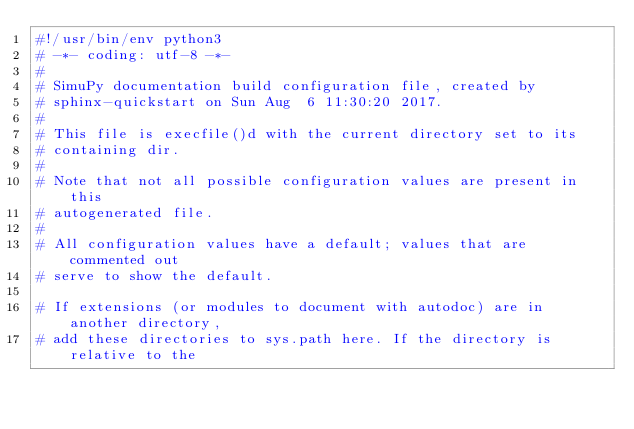Convert code to text. <code><loc_0><loc_0><loc_500><loc_500><_Python_>#!/usr/bin/env python3
# -*- coding: utf-8 -*-
#
# SimuPy documentation build configuration file, created by
# sphinx-quickstart on Sun Aug  6 11:30:20 2017.
#
# This file is execfile()d with the current directory set to its
# containing dir.
#
# Note that not all possible configuration values are present in this
# autogenerated file.
#
# All configuration values have a default; values that are commented out
# serve to show the default.

# If extensions (or modules to document with autodoc) are in another directory,
# add these directories to sys.path here. If the directory is relative to the</code> 